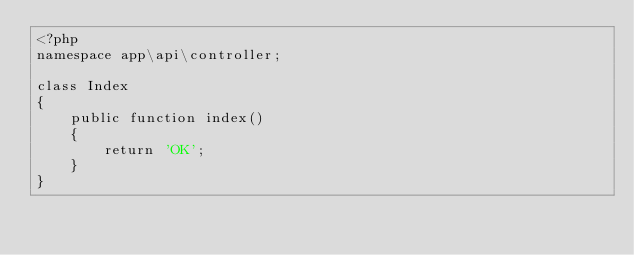Convert code to text. <code><loc_0><loc_0><loc_500><loc_500><_PHP_><?php
namespace app\api\controller;

class Index
{
    public function index()
    {
        return 'OK';
    }
}
</code> 